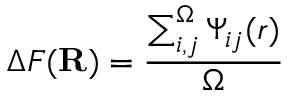Convert formula to latex. <formula><loc_0><loc_0><loc_500><loc_500>\Delta F ( R ) = \frac { \sum _ { i , j } ^ { \Omega } \Psi _ { i j } ( r ) } { \Omega }</formula> 